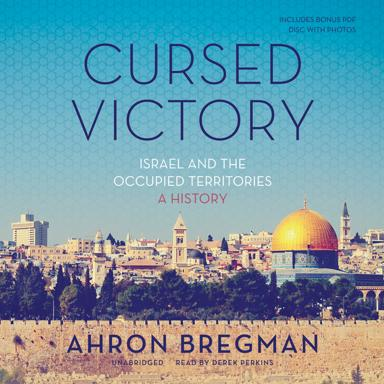What is the title of the book mentioned in the image? The title of the book depicted in the image is "Cursed Victory: Israel and the Occupied Territories: A History", authored by Ahron Bregman, offering an in-depth exploration of the complex historical context. 